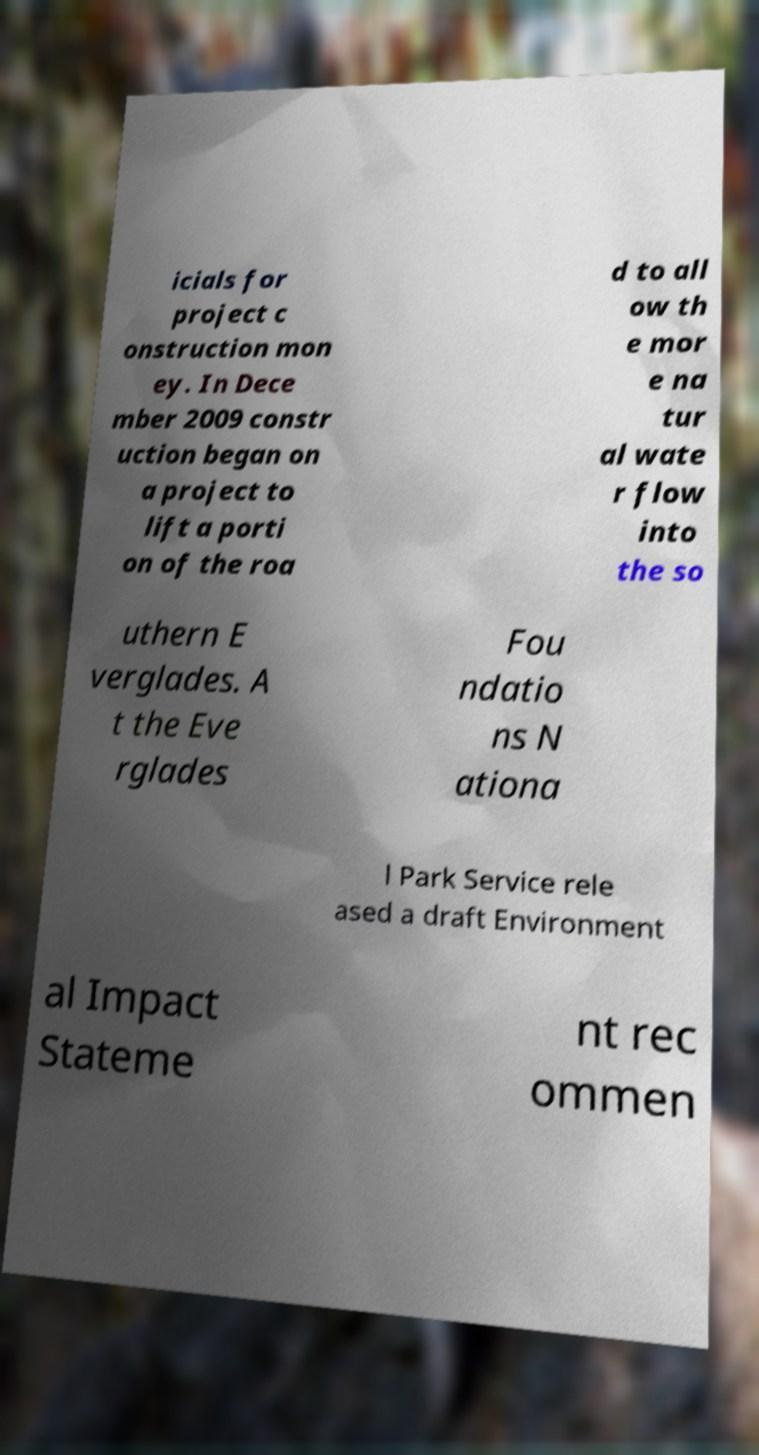What messages or text are displayed in this image? I need them in a readable, typed format. icials for project c onstruction mon ey. In Dece mber 2009 constr uction began on a project to lift a porti on of the roa d to all ow th e mor e na tur al wate r flow into the so uthern E verglades. A t the Eve rglades Fou ndatio ns N ationa l Park Service rele ased a draft Environment al Impact Stateme nt rec ommen 